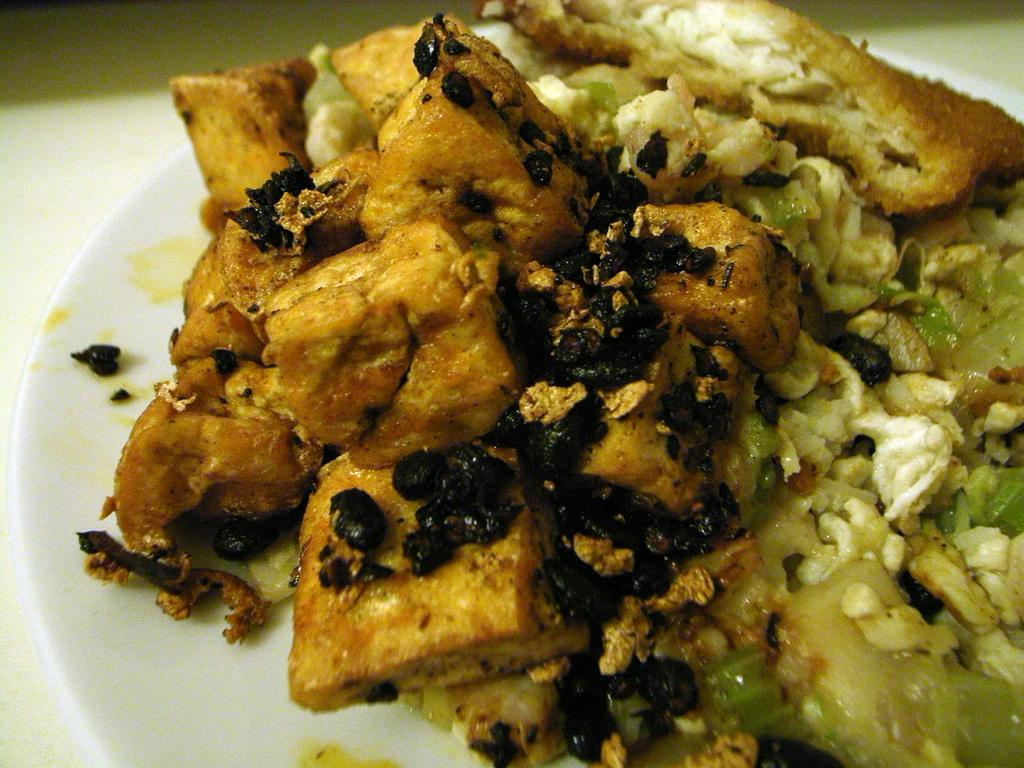What is on the plate that is visible in the image? There are food items on the plate in the image. Where is the plate located in the image? The plate is placed on a table in the image. Can you describe the setting where the plate is located? The image may have been taken in a room, but this cannot be confirmed without more context. How many owls can be seen in the image? There are no owls present in the image. What type of light is being used to illuminate the food items in the image? The type of light cannot be determined from the image, as there is no information provided about the lighting source. 